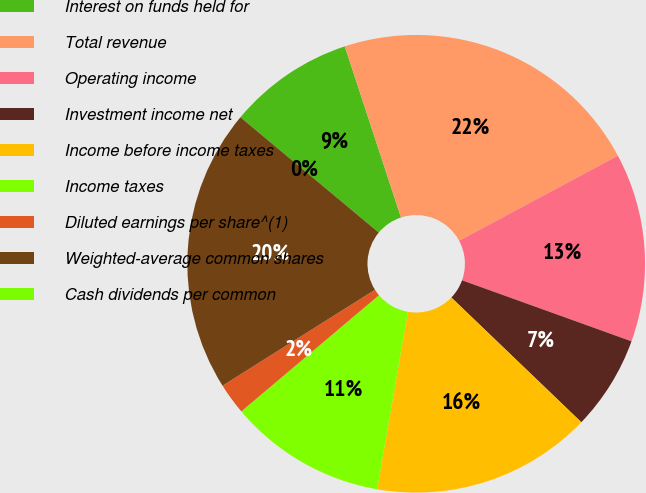Convert chart to OTSL. <chart><loc_0><loc_0><loc_500><loc_500><pie_chart><fcel>Interest on funds held for<fcel>Total revenue<fcel>Operating income<fcel>Investment income net<fcel>Income before income taxes<fcel>Income taxes<fcel>Diluted earnings per share^(1)<fcel>Weighted-average common shares<fcel>Cash dividends per common<nl><fcel>8.89%<fcel>22.22%<fcel>13.33%<fcel>6.67%<fcel>15.56%<fcel>11.11%<fcel>2.22%<fcel>20.0%<fcel>0.0%<nl></chart> 